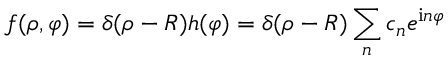<formula> <loc_0><loc_0><loc_500><loc_500>f ( \rho , \varphi ) = \delta ( \rho - R ) h ( \varphi ) = \delta ( \rho - R ) \sum _ { n } c _ { n } e ^ { i n \varphi }</formula> 